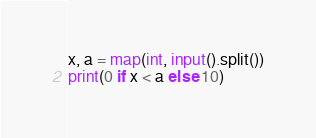<code> <loc_0><loc_0><loc_500><loc_500><_Python_>x, a = map(int, input().split())
print(0 if x < a else 10)</code> 